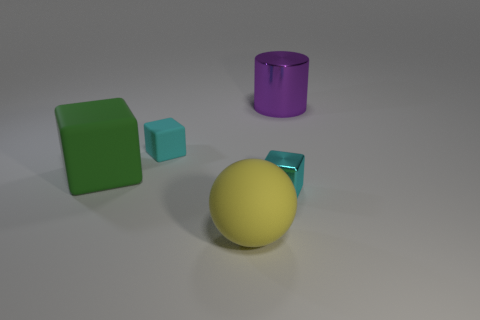Add 1 large spheres. How many objects exist? 6 Subtract all spheres. How many objects are left? 4 Subtract 1 purple cylinders. How many objects are left? 4 Subtract all large red cubes. Subtract all big purple shiny cylinders. How many objects are left? 4 Add 3 rubber cubes. How many rubber cubes are left? 5 Add 3 metal objects. How many metal objects exist? 5 